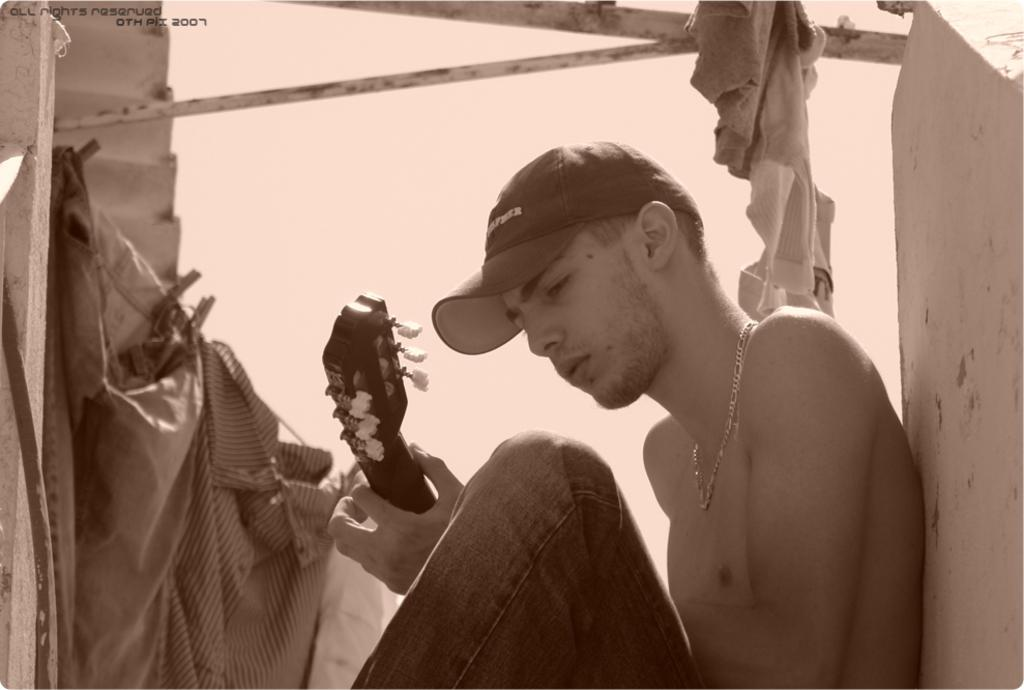What is the color scheme of the image? The image is black and white. Who is present in the image? There is a man in the image. What is the man holding in the image? The man is holding a musical instrument. What object can be seen in the image that resembles a long, thin stick? There is a rod in the image. What type of personal belongings can be seen in the image? There are clothes in the image. What type of structure is visible in the background of the image? There is a wall in the image. How many spiders are crawling on the wall in the image? There are no spiders visible in the image; it only shows a man holding a musical instrument, a rod, clothes, and a wall. What type of locket is the man wearing in the image? There is no locket visible in the image; the man is only holding a musical instrument. 